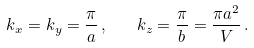<formula> <loc_0><loc_0><loc_500><loc_500>k _ { x } = k _ { y } = \frac { \pi } { a } \, , \quad k _ { z } = \frac { \pi } { b } = \frac { \pi a ^ { 2 } } { V } \, .</formula> 